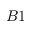Convert formula to latex. <formula><loc_0><loc_0><loc_500><loc_500>B 1</formula> 